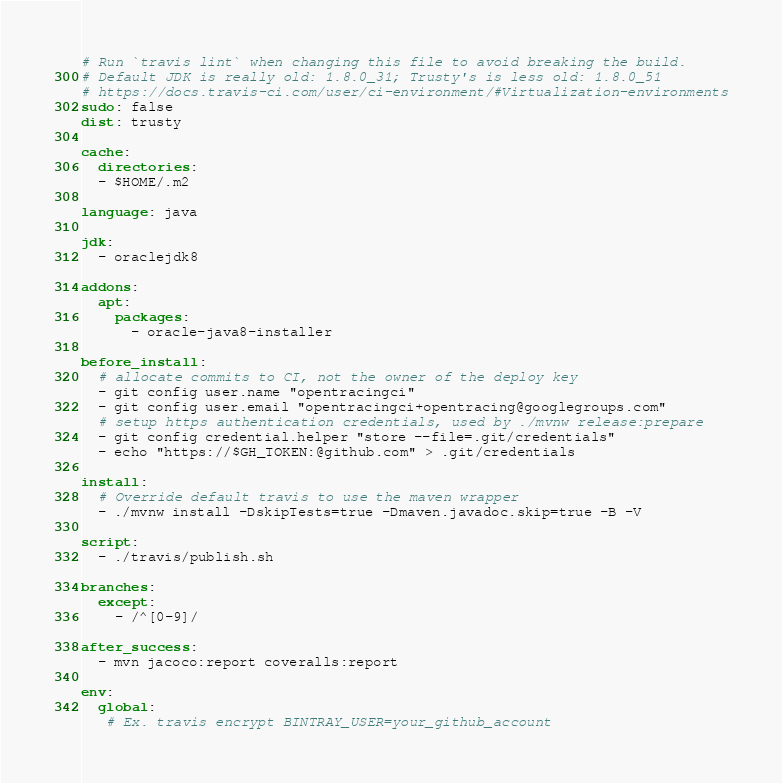<code> <loc_0><loc_0><loc_500><loc_500><_YAML_># Run `travis lint` when changing this file to avoid breaking the build.
# Default JDK is really old: 1.8.0_31; Trusty's is less old: 1.8.0_51
# https://docs.travis-ci.com/user/ci-environment/#Virtualization-environments
sudo: false
dist: trusty

cache:
  directories:
  - $HOME/.m2

language: java

jdk:
  - oraclejdk8

addons:
  apt:
    packages:
      - oracle-java8-installer

before_install:
  # allocate commits to CI, not the owner of the deploy key
  - git config user.name "opentracingci"
  - git config user.email "opentracingci+opentracing@googlegroups.com"
  # setup https authentication credentials, used by ./mvnw release:prepare
  - git config credential.helper "store --file=.git/credentials"
  - echo "https://$GH_TOKEN:@github.com" > .git/credentials

install:
  # Override default travis to use the maven wrapper
  - ./mvnw install -DskipTests=true -Dmaven.javadoc.skip=true -B -V

script:
  - ./travis/publish.sh

branches:
  except:
    - /^[0-9]/

after_success:
  - mvn jacoco:report coveralls:report

env:
  global:
   # Ex. travis encrypt BINTRAY_USER=your_github_account</code> 